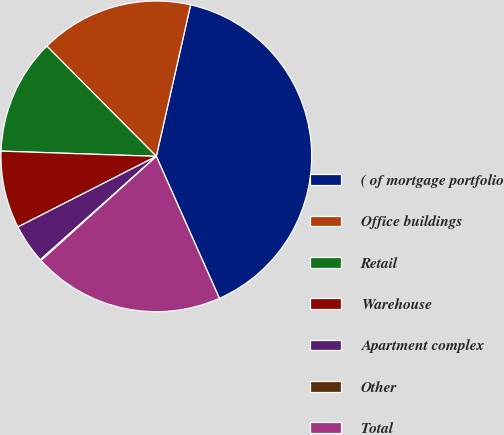Convert chart. <chart><loc_0><loc_0><loc_500><loc_500><pie_chart><fcel>( of mortgage portfolio<fcel>Office buildings<fcel>Retail<fcel>Warehouse<fcel>Apartment complex<fcel>Other<fcel>Total<nl><fcel>39.81%<fcel>15.99%<fcel>12.02%<fcel>8.05%<fcel>4.08%<fcel>0.11%<fcel>19.96%<nl></chart> 